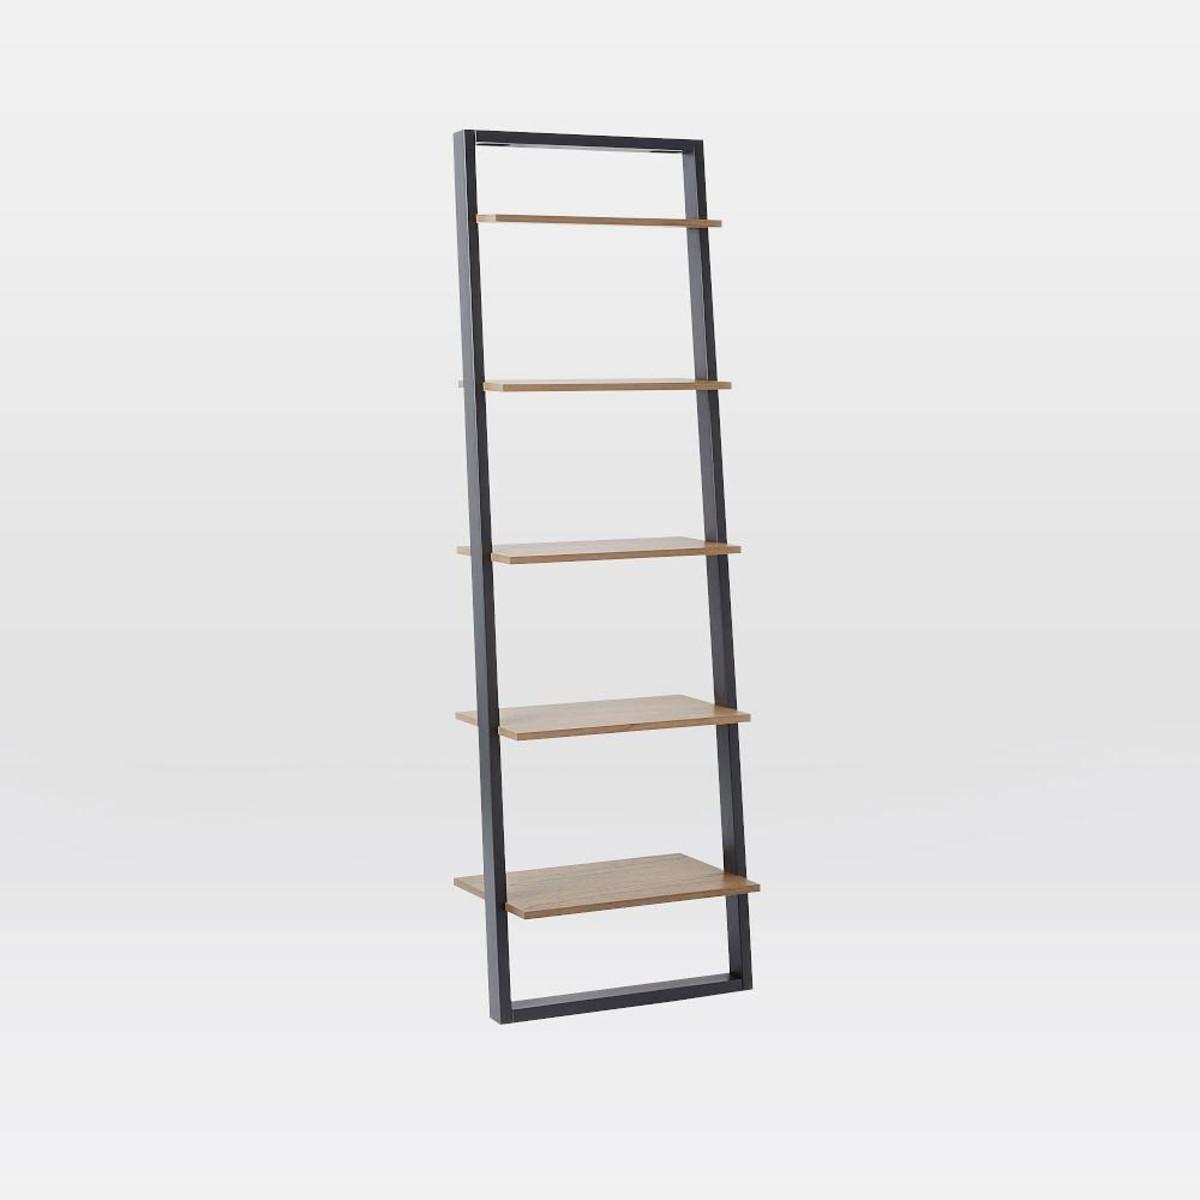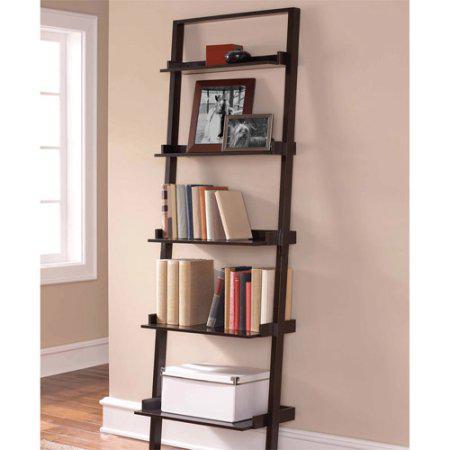The first image is the image on the left, the second image is the image on the right. For the images shown, is this caption "At least one of the bookshelves has four legs in the shape of an inverted v." true? Answer yes or no. No. The first image is the image on the left, the second image is the image on the right. Analyze the images presented: Is the assertion "At least one shelf has items on it." valid? Answer yes or no. Yes. 